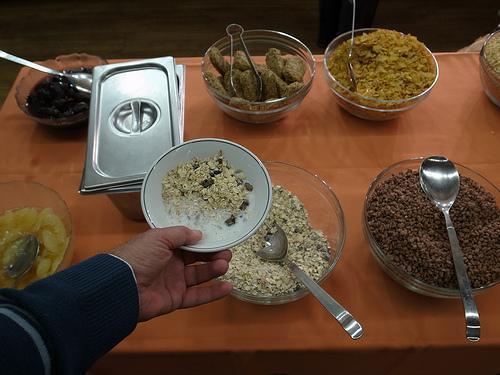How many people are in this photo?
Give a very brief answer. 1. How many serving spoons are seen here?
Give a very brief answer. 5. How many different cereals are being served?
Give a very brief answer. 3. How many sets of tongs are on the table?
Give a very brief answer. 1. How many lids are pictured?
Give a very brief answer. 1. How many bowls are pictured?
Give a very brief answer. 7. 